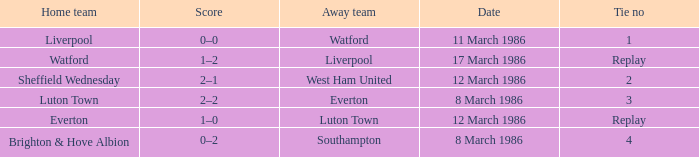What was the tie resulting from Sheffield Wednesday's game? 2.0. 